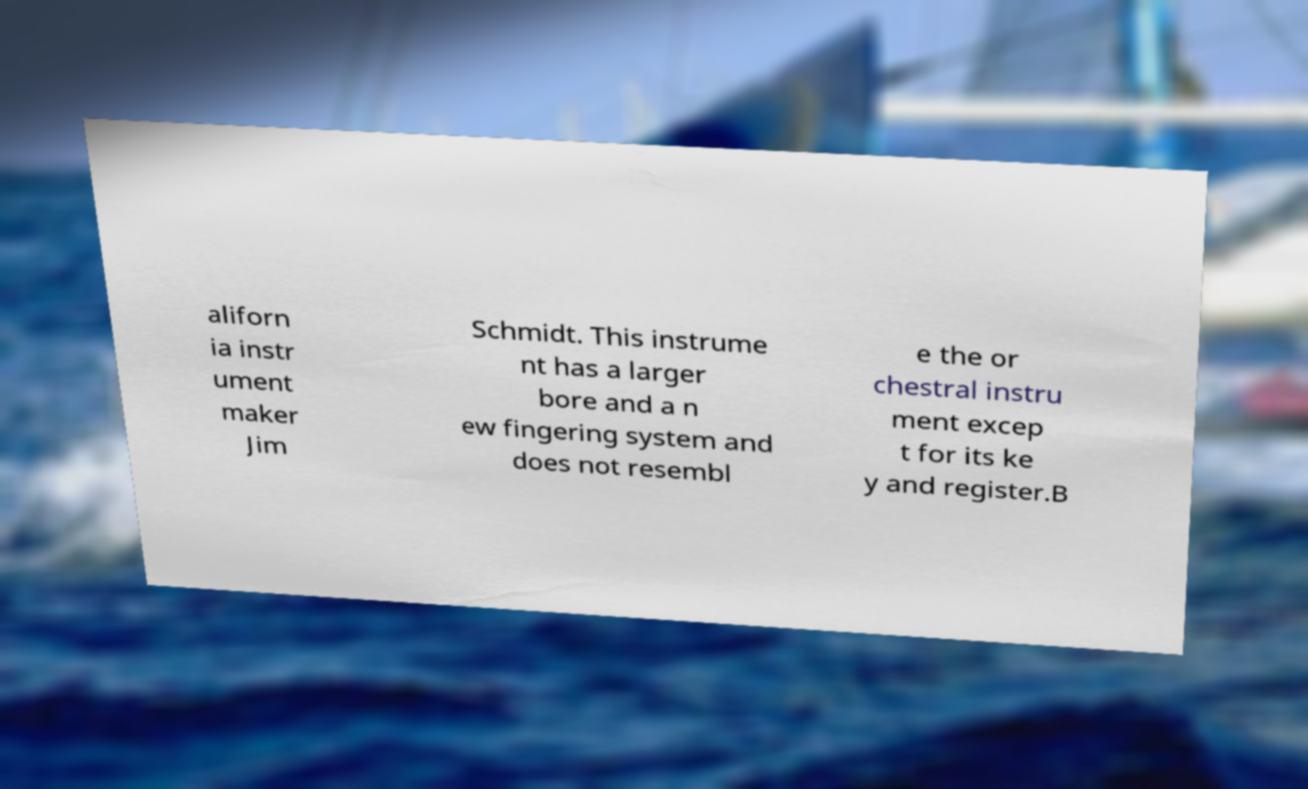There's text embedded in this image that I need extracted. Can you transcribe it verbatim? aliforn ia instr ument maker Jim Schmidt. This instrume nt has a larger bore and a n ew fingering system and does not resembl e the or chestral instru ment excep t for its ke y and register.B 